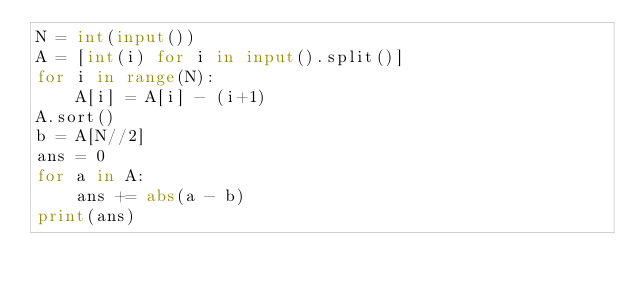Convert code to text. <code><loc_0><loc_0><loc_500><loc_500><_Python_>N = int(input())
A = [int(i) for i in input().split()]
for i in range(N):
    A[i] = A[i] - (i+1)
A.sort()
b = A[N//2]
ans = 0
for a in A:
    ans += abs(a - b)
print(ans)
</code> 